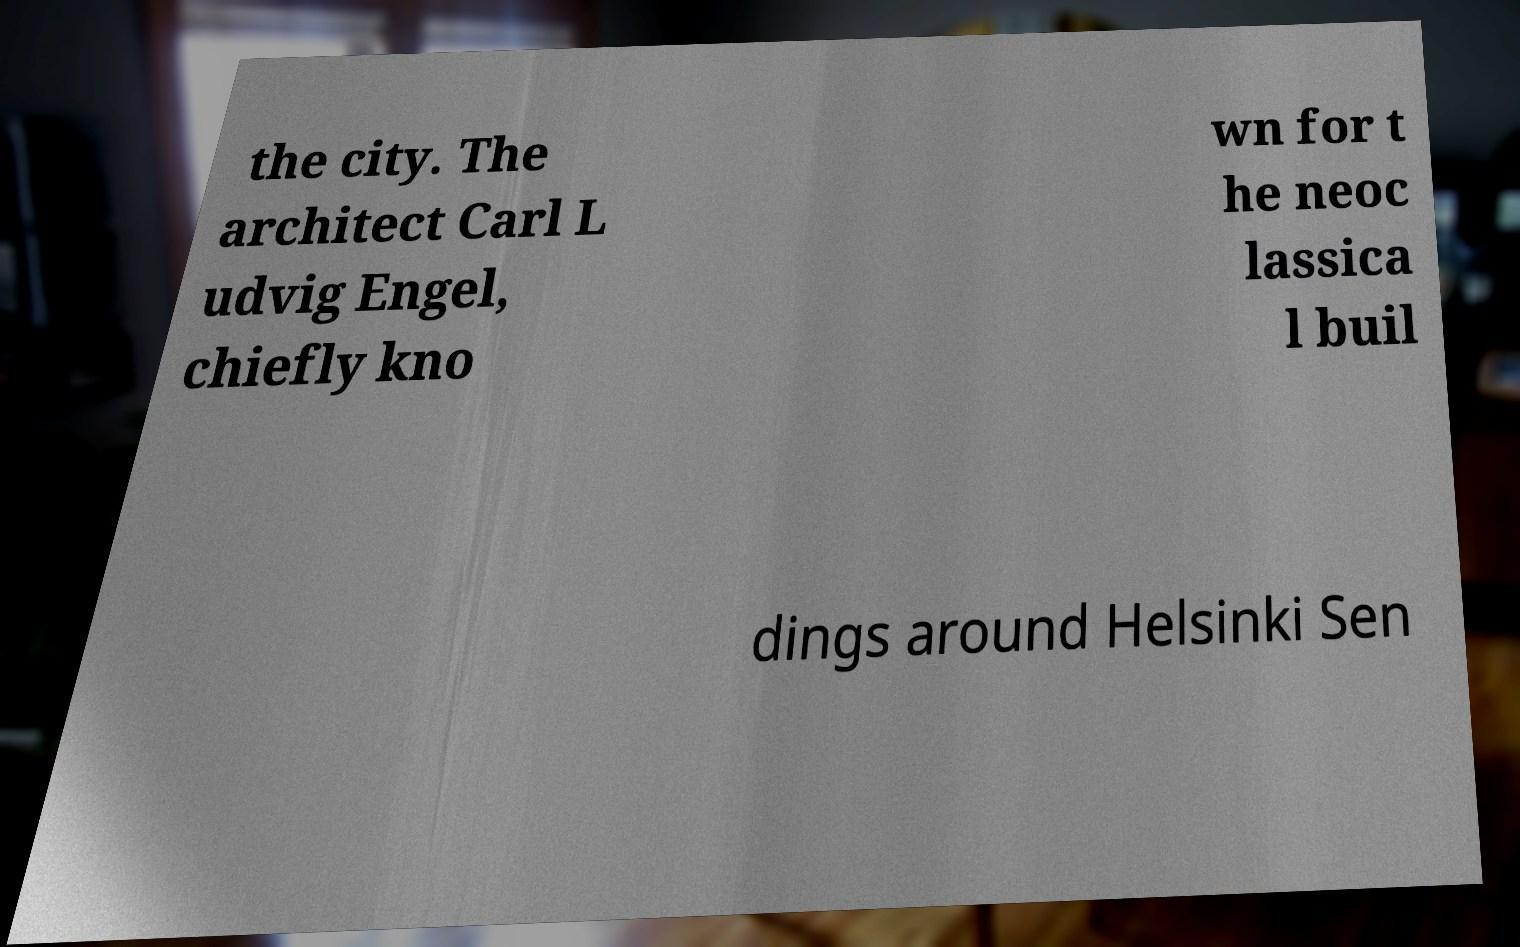For documentation purposes, I need the text within this image transcribed. Could you provide that? the city. The architect Carl L udvig Engel, chiefly kno wn for t he neoc lassica l buil dings around Helsinki Sen 